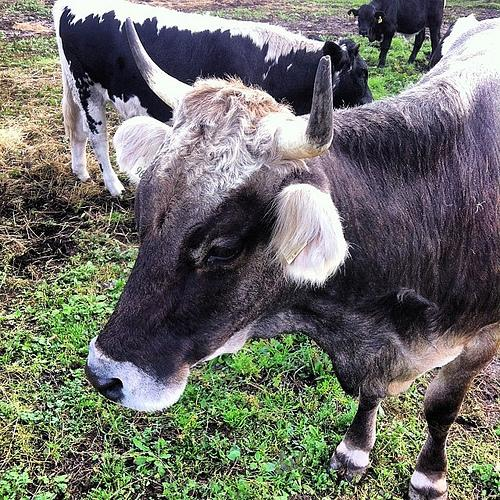How would you describe the image's overall environment? The image illustrates a group of cows with various patterns and horns standing in a grassy field with patches of dead grass and dirt. Describe the grass and ground in the image. The image features green grass, yellow dead grass, and brown dirt on the ground, along with some weeds growing in the field. What are the notable features of the horns in the image? There are large horns on the gray and white cows, and the image shows the left and right horns on the cows' heads distinctly. Discuss the appearance of the largest cow in the image. The largest cow has gray and white fur, large horns on its head, and tags in both of its ears, alongside distinctive eyes and hoofs. Mention the unique features of the cows in the image. There are cows with gray and white fur, black spots, horns, and yellow tags on their ears, as well as a black cow in the background. Give a summary of the cows' body parts that are visible in the image. In the image, we can see the cows' eyes, noses, ears with tags, horns, front legs, and hoofs, as well as the fur of various colors. Describe the texture of the ground in the image. The ground in the image has a mix of green grass, dead yellow grass, brown dirt patches, and some weeds growing on the field. What is the dominant color of the cows in the image? The dominant color of the cows in the image is a mix of gray and white, with some having black spots. Mention attributes of the cow with yellow tags. The cow with yellow tags has a distinct black fur, horns, an eye, and edges of its ear that are clearly visible in the image. Provide a brief overview of the scene depicted in the image. The image shows various cows with different fur colors and horns standing in a grassy field with patches of dirt and dead grass. 